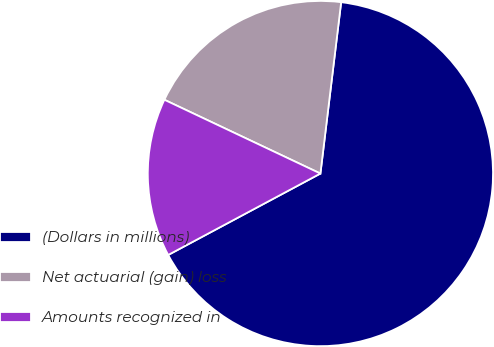Convert chart. <chart><loc_0><loc_0><loc_500><loc_500><pie_chart><fcel>(Dollars in millions)<fcel>Net actuarial (gain) loss<fcel>Amounts recognized in<nl><fcel>65.27%<fcel>19.89%<fcel>14.85%<nl></chart> 